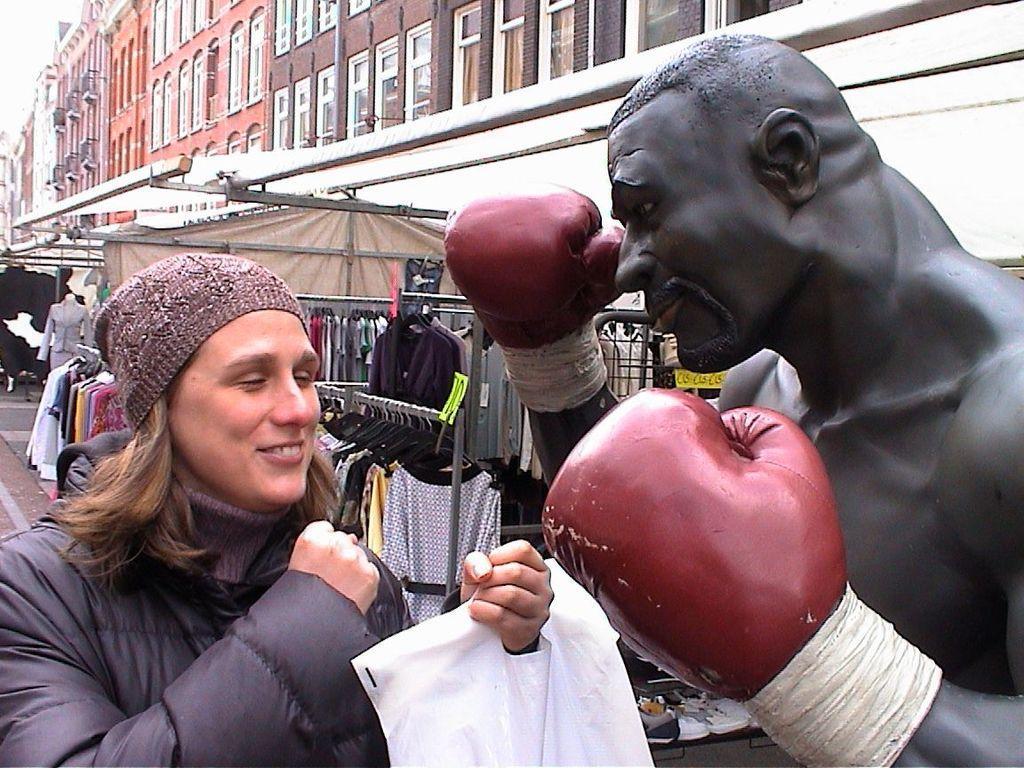Can you describe this image briefly? In this image we can see a woman holding a cover standing beside a statue. On the backside we can see the clothing changed to the hangers, a mannequin and a group of buildings with windows. 